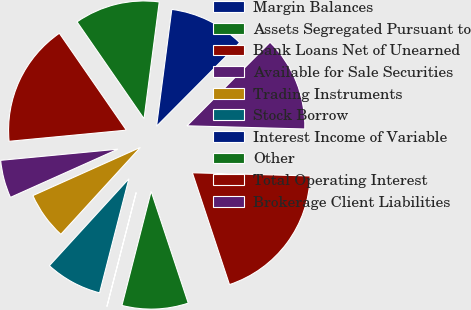Convert chart to OTSL. <chart><loc_0><loc_0><loc_500><loc_500><pie_chart><fcel>Margin Balances<fcel>Assets Segregated Pursuant to<fcel>Bank Loans Net of Unearned<fcel>Available for Sale Securities<fcel>Trading Instruments<fcel>Stock Borrow<fcel>Interest Income of Variable<fcel>Other<fcel>Total Operating Interest<fcel>Brokerage Client Liabilities<nl><fcel>10.39%<fcel>11.69%<fcel>16.88%<fcel>5.2%<fcel>6.5%<fcel>7.79%<fcel>0.01%<fcel>9.09%<fcel>19.47%<fcel>12.98%<nl></chart> 